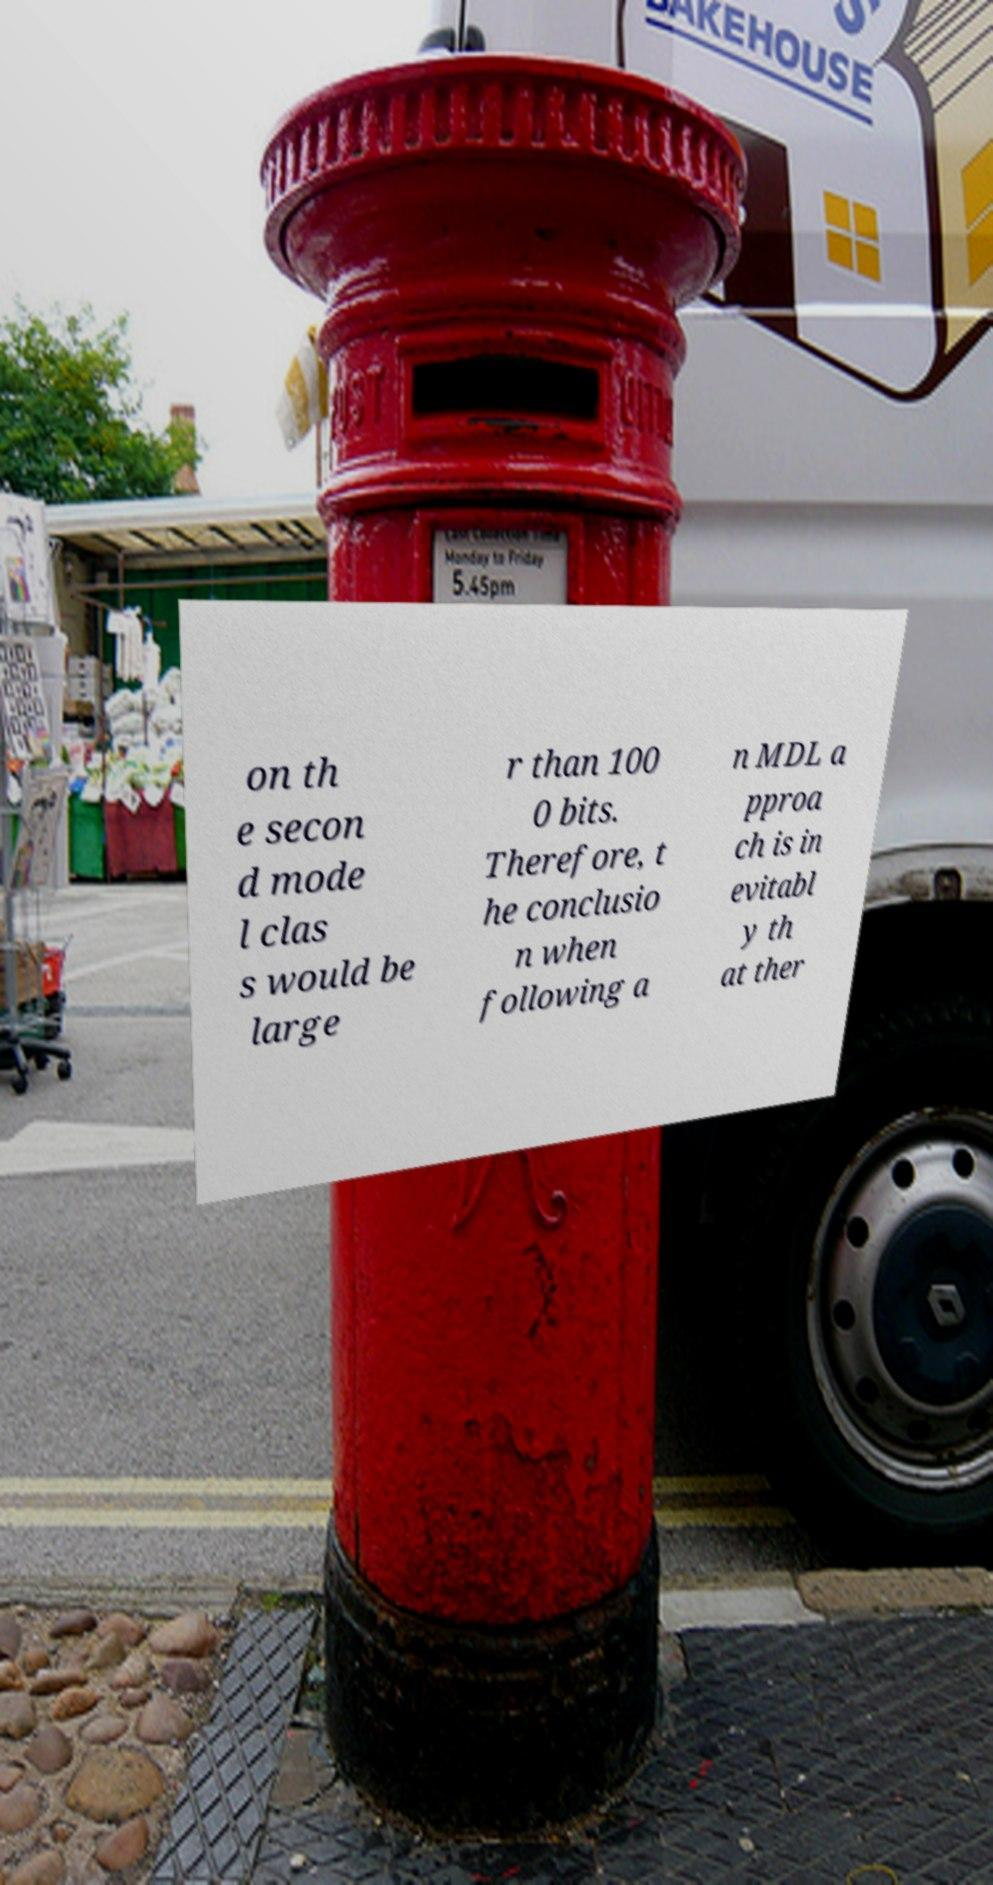Please read and relay the text visible in this image. What does it say? on th e secon d mode l clas s would be large r than 100 0 bits. Therefore, t he conclusio n when following a n MDL a pproa ch is in evitabl y th at ther 